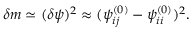Convert formula to latex. <formula><loc_0><loc_0><loc_500><loc_500>\delta m \simeq ( \delta \psi ) ^ { 2 } \approx ( \psi _ { i j } ^ { ( 0 ) } - \psi _ { i i } ^ { ( 0 ) } ) ^ { 2 } .</formula> 